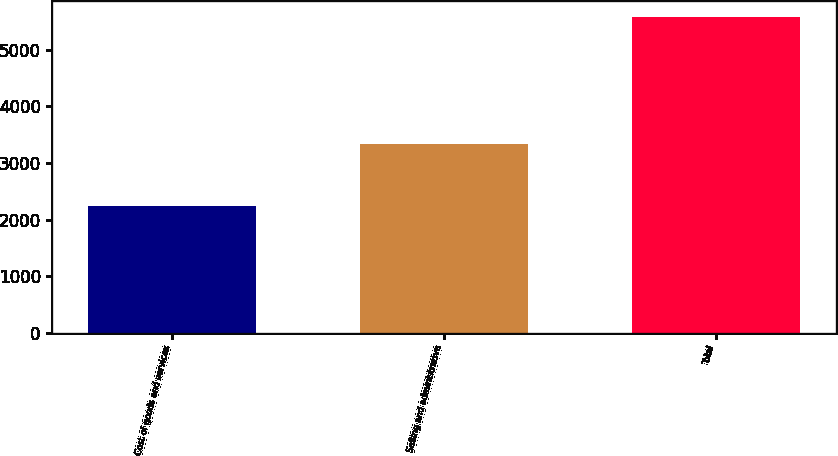<chart> <loc_0><loc_0><loc_500><loc_500><bar_chart><fcel>Cost of goods and services<fcel>Selling and administrative<fcel>Total<nl><fcel>2243<fcel>3340<fcel>5583<nl></chart> 